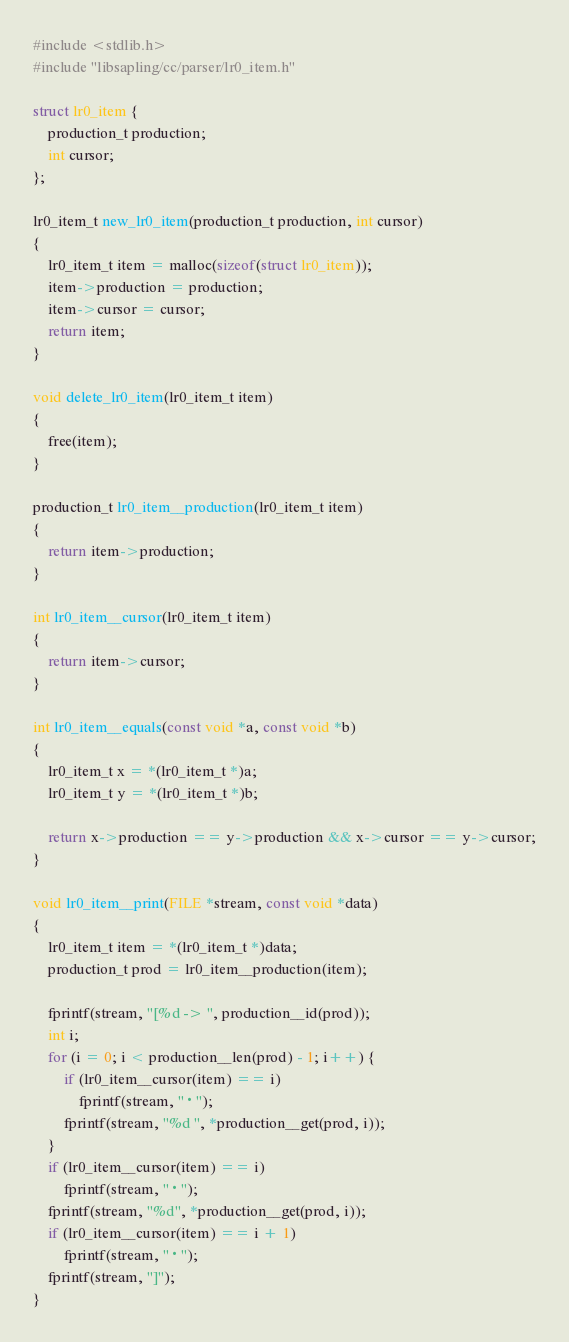Convert code to text. <code><loc_0><loc_0><loc_500><loc_500><_C_>#include <stdlib.h>
#include "libsapling/cc/parser/lr0_item.h"

struct lr0_item {
    production_t production;
    int cursor;
};

lr0_item_t new_lr0_item(production_t production, int cursor)
{
    lr0_item_t item = malloc(sizeof(struct lr0_item));
    item->production = production;
    item->cursor = cursor;
    return item;
}

void delete_lr0_item(lr0_item_t item)
{
    free(item);
}

production_t lr0_item__production(lr0_item_t item)
{
    return item->production;
}

int lr0_item__cursor(lr0_item_t item)
{
    return item->cursor;
}

int lr0_item__equals(const void *a, const void *b)
{
    lr0_item_t x = *(lr0_item_t *)a;
    lr0_item_t y = *(lr0_item_t *)b;

    return x->production == y->production && x->cursor == y->cursor;
}

void lr0_item__print(FILE *stream, const void *data)
{
    lr0_item_t item = *(lr0_item_t *)data;
    production_t prod = lr0_item__production(item);

    fprintf(stream, "[%d -> ", production__id(prod));
    int i;
    for (i = 0; i < production__len(prod) - 1; i++) {
        if (lr0_item__cursor(item) == i)
            fprintf(stream, "·");
        fprintf(stream, "%d ", *production__get(prod, i));
    }
    if (lr0_item__cursor(item) == i)
        fprintf(stream, "·");
    fprintf(stream, "%d", *production__get(prod, i));
    if (lr0_item__cursor(item) == i + 1)
        fprintf(stream, "·");
    fprintf(stream, "]");
}
</code> 